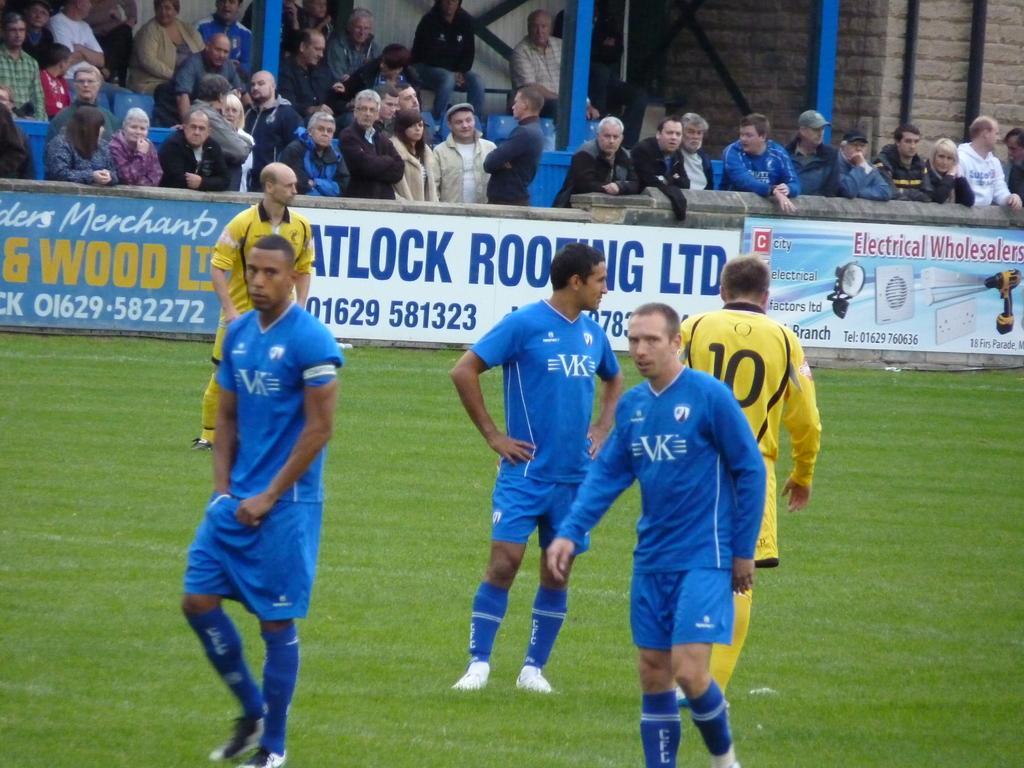In one or two sentences, can you explain what this image depicts? In this picture we can see some people standing on the ground and in the background we can see a wall,advertising boards,people,poles. 